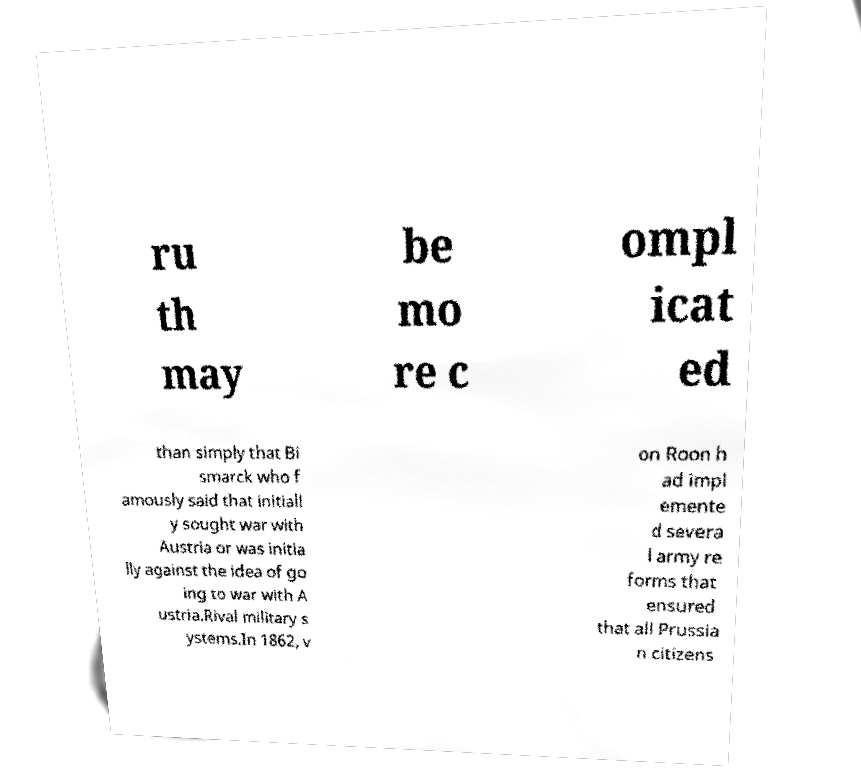Could you assist in decoding the text presented in this image and type it out clearly? ru th may be mo re c ompl icat ed than simply that Bi smarck who f amously said that initiall y sought war with Austria or was initia lly against the idea of go ing to war with A ustria.Rival military s ystems.In 1862, v on Roon h ad impl emente d severa l army re forms that ensured that all Prussia n citizens 